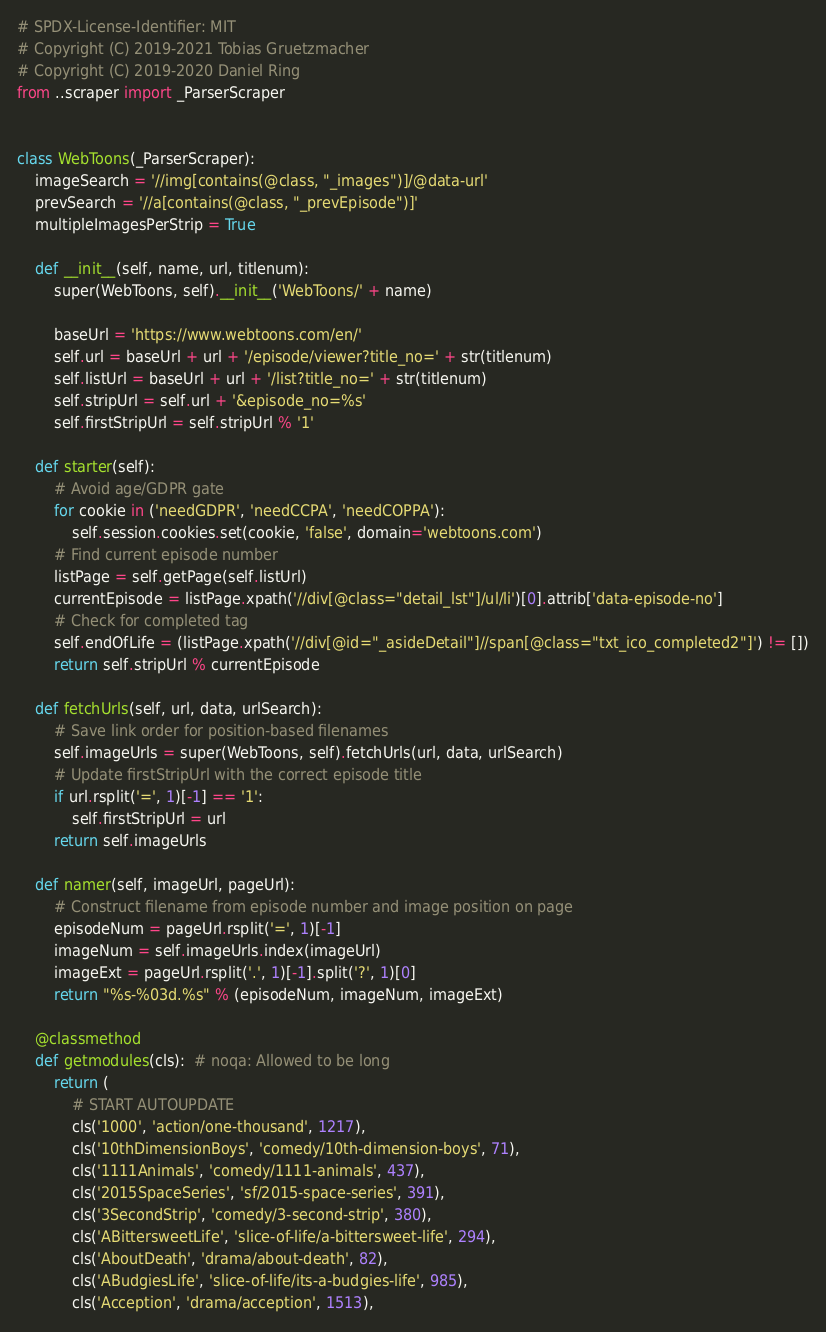<code> <loc_0><loc_0><loc_500><loc_500><_Python_># SPDX-License-Identifier: MIT
# Copyright (C) 2019-2021 Tobias Gruetzmacher
# Copyright (C) 2019-2020 Daniel Ring
from ..scraper import _ParserScraper


class WebToons(_ParserScraper):
    imageSearch = '//img[contains(@class, "_images")]/@data-url'
    prevSearch = '//a[contains(@class, "_prevEpisode")]'
    multipleImagesPerStrip = True

    def __init__(self, name, url, titlenum):
        super(WebToons, self).__init__('WebToons/' + name)

        baseUrl = 'https://www.webtoons.com/en/'
        self.url = baseUrl + url + '/episode/viewer?title_no=' + str(titlenum)
        self.listUrl = baseUrl + url + '/list?title_no=' + str(titlenum)
        self.stripUrl = self.url + '&episode_no=%s'
        self.firstStripUrl = self.stripUrl % '1'

    def starter(self):
        # Avoid age/GDPR gate
        for cookie in ('needGDPR', 'needCCPA', 'needCOPPA'):
            self.session.cookies.set(cookie, 'false', domain='webtoons.com')
        # Find current episode number
        listPage = self.getPage(self.listUrl)
        currentEpisode = listPage.xpath('//div[@class="detail_lst"]/ul/li')[0].attrib['data-episode-no']
        # Check for completed tag
        self.endOfLife = (listPage.xpath('//div[@id="_asideDetail"]//span[@class="txt_ico_completed2"]') != [])
        return self.stripUrl % currentEpisode

    def fetchUrls(self, url, data, urlSearch):
        # Save link order for position-based filenames
        self.imageUrls = super(WebToons, self).fetchUrls(url, data, urlSearch)
        # Update firstStripUrl with the correct episode title
        if url.rsplit('=', 1)[-1] == '1':
            self.firstStripUrl = url
        return self.imageUrls

    def namer(self, imageUrl, pageUrl):
        # Construct filename from episode number and image position on page
        episodeNum = pageUrl.rsplit('=', 1)[-1]
        imageNum = self.imageUrls.index(imageUrl)
        imageExt = pageUrl.rsplit('.', 1)[-1].split('?', 1)[0]
        return "%s-%03d.%s" % (episodeNum, imageNum, imageExt)

    @classmethod
    def getmodules(cls):  # noqa: Allowed to be long
        return (
            # START AUTOUPDATE
            cls('1000', 'action/one-thousand', 1217),
            cls('10thDimensionBoys', 'comedy/10th-dimension-boys', 71),
            cls('1111Animals', 'comedy/1111-animals', 437),
            cls('2015SpaceSeries', 'sf/2015-space-series', 391),
            cls('3SecondStrip', 'comedy/3-second-strip', 380),
            cls('ABittersweetLife', 'slice-of-life/a-bittersweet-life', 294),
            cls('AboutDeath', 'drama/about-death', 82),
            cls('ABudgiesLife', 'slice-of-life/its-a-budgies-life', 985),
            cls('Acception', 'drama/acception', 1513),</code> 